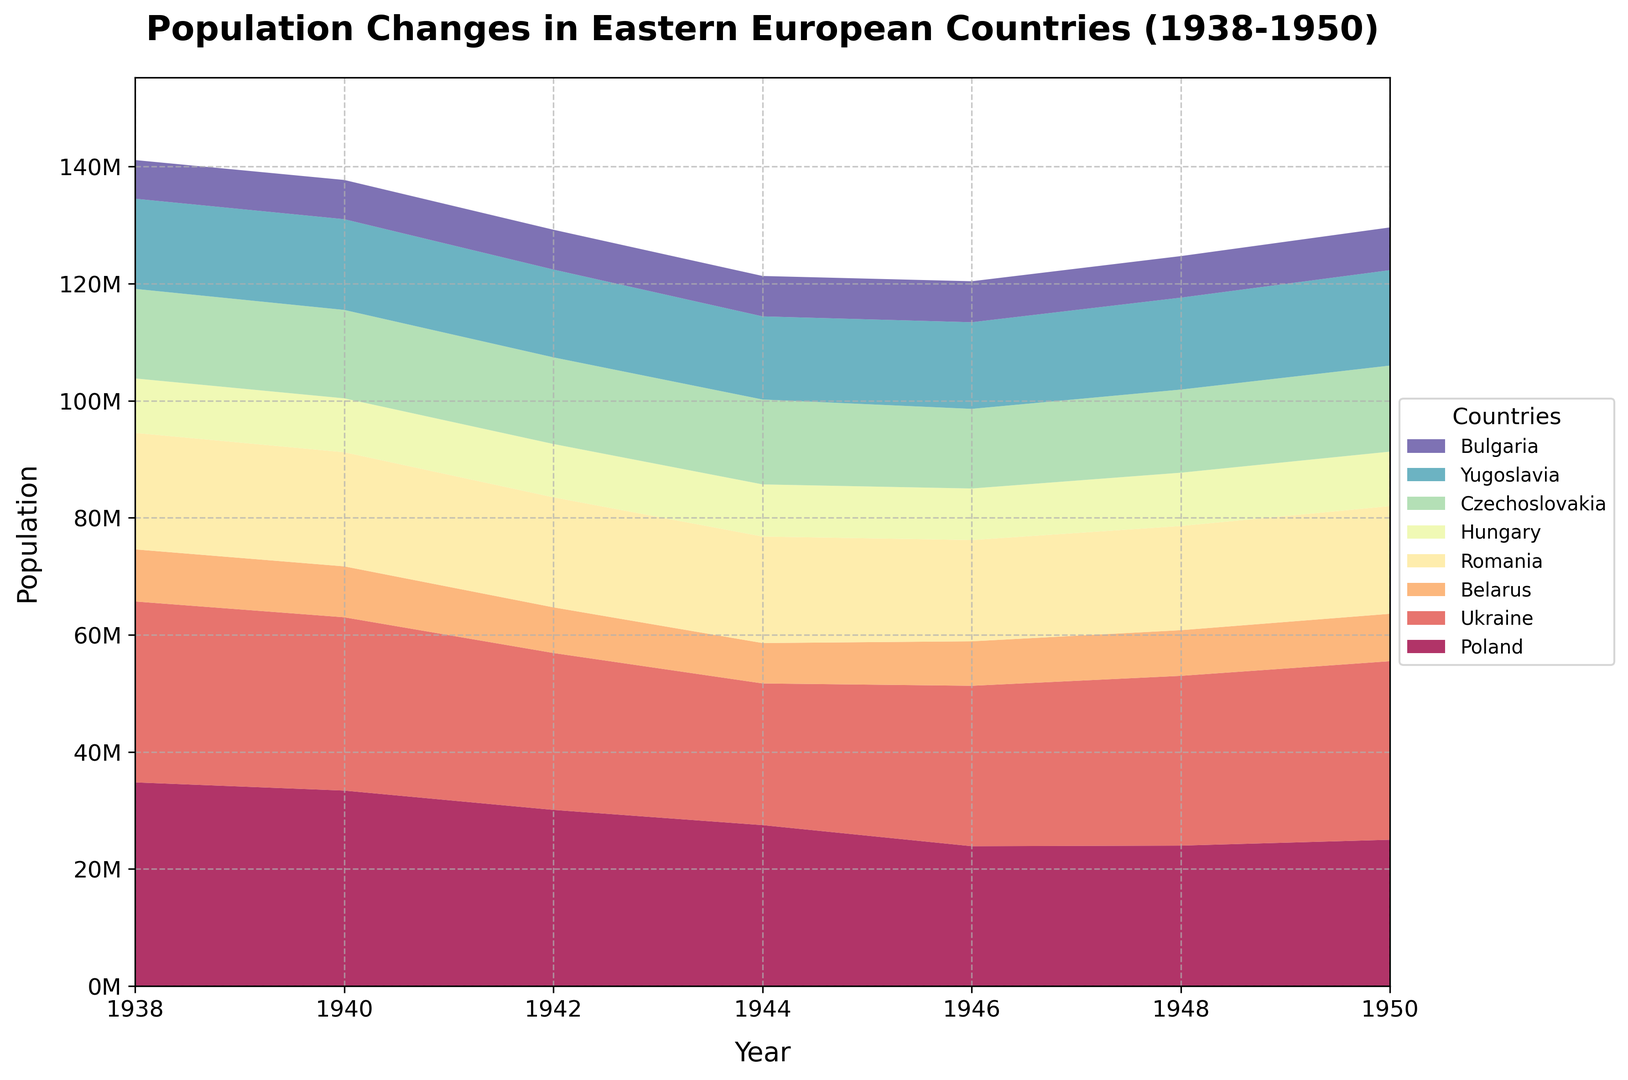What is the total population loss in Poland from 1938 to 1946? First, note the population in Poland in 1938 (34,800,000) and in 1946 (23,900,000). Compute the difference: 34,800,000 - 23,900,000 = 10,900,000.
Answer: 10,900,000 Which country had the smallest population in 1950? Review the population data for 1950: Poland (25,000,000), Ukraine (30,500,000), Belarus (8,100,000), Romania (18,400,000), Hungary (9,300,000), Czechoslovakia (14,700,000), Yugoslavia (16,300,000), Bulgaria (7,300,000). Belarus has the smallest population.
Answer: Belarus By what percentage did the population of Poland decrease from 1938 to 1944? First, find the population in 1938 (34,800,000) and in 1944 (27,500,000). Compute the difference: 34,800,000 - 27,500,000 = 7,300,000. Now find the percentage decrease: (7,300,000 / 34,800,000) * 100 ≈ 20.98%.
Answer: ~21% Which country experienced the most significant population growth between 1946 and 1950? Check the population changes from 1946 to 1950 for each country: Poland (23,900,000 to 25,000,000), Ukraine (27,400,000 to 30,500,000), Belarus (7,600,000 to 8,100,000), Romania (17,300,000 to 18,400,000), Hungary (8,800,000 to 9,300,000), Czechoslovakia (13,600,000 to 14,700,000), Yugoslavia (14,800,000 to 16,300,000), Bulgaria (7,000,000 to 7,300,000). Ukraine had the largest increase (3,100,000).
Answer: Ukraine How does the population trend of Bulgaria differ visually from the other countries? Observe that Bulgaria's population consistently increased from 1938 to 1950 while several other countries, such as Poland and Ukraine, showed significant decreases during the war years.
Answer: Consistent increase Which country had the highest population in 1938, and how does it compare to the highest population in 1950? In 1938, Poland had the highest population (34,800,000), and in 1950, Ukraine had the highest (30,500,000). The highest population in 1950 was lower than in 1938 by 4,300,000.
Answer: Poland (1938), Ukraine (1950) What was the approximate average population of Czechoslovakia from 1938 to 1950? Sum the populations of Czechoslovakia from 1938 (15,300,000), 1940 (15,100,000), 1942 (14,800,000), 1944 (14,500,000), 1946 (13,600,000), 1948 (14,200,000), and 1950 (14,700,000). The total is 102,200,000. Divide by 7 (number of years) to get the average: 102,200,000 / 7 ≈ 14,600,000.
Answer: ~14,600,000 Which country showed the most stable population during the entire period from 1938 to 1950? Review the population data for each country and notice that Hungary's population shows the least fluctuations with values ranging between 8.9 to 9.3 million from 1938 to 1950.
Answer: Hungary 